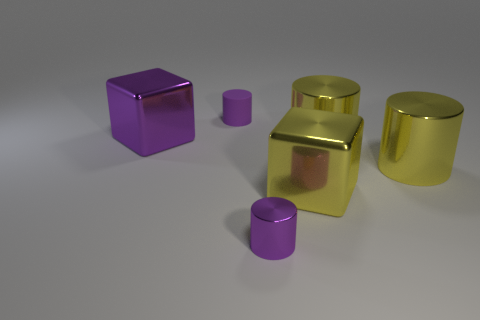Subtract all cyan balls. How many yellow cylinders are left? 2 Subtract all tiny purple metal cylinders. How many cylinders are left? 3 Add 3 large purple metallic spheres. How many objects exist? 9 Subtract all cubes. How many objects are left? 4 Subtract 1 blocks. How many blocks are left? 1 Subtract 0 blue cubes. How many objects are left? 6 Subtract all purple blocks. Subtract all green cylinders. How many blocks are left? 1 Subtract all large yellow metallic objects. Subtract all large yellow shiny cylinders. How many objects are left? 1 Add 2 cylinders. How many cylinders are left? 6 Add 6 matte things. How many matte things exist? 7 